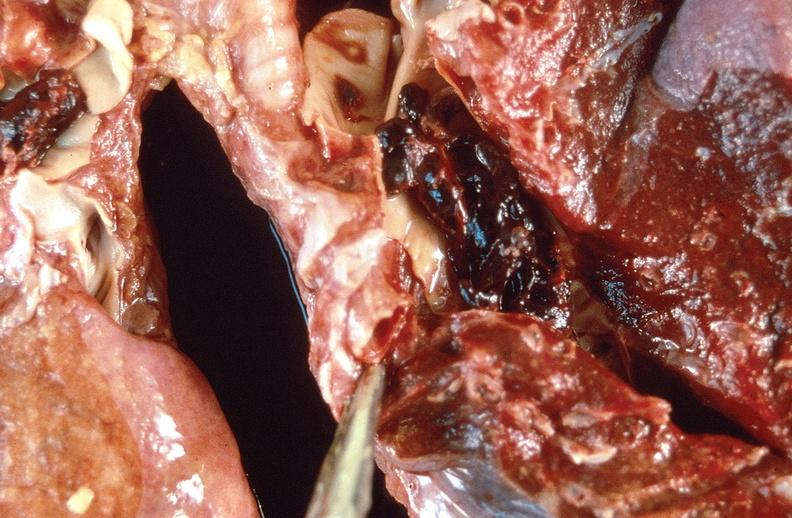what is present?
Answer the question using a single word or phrase. Respiratory 